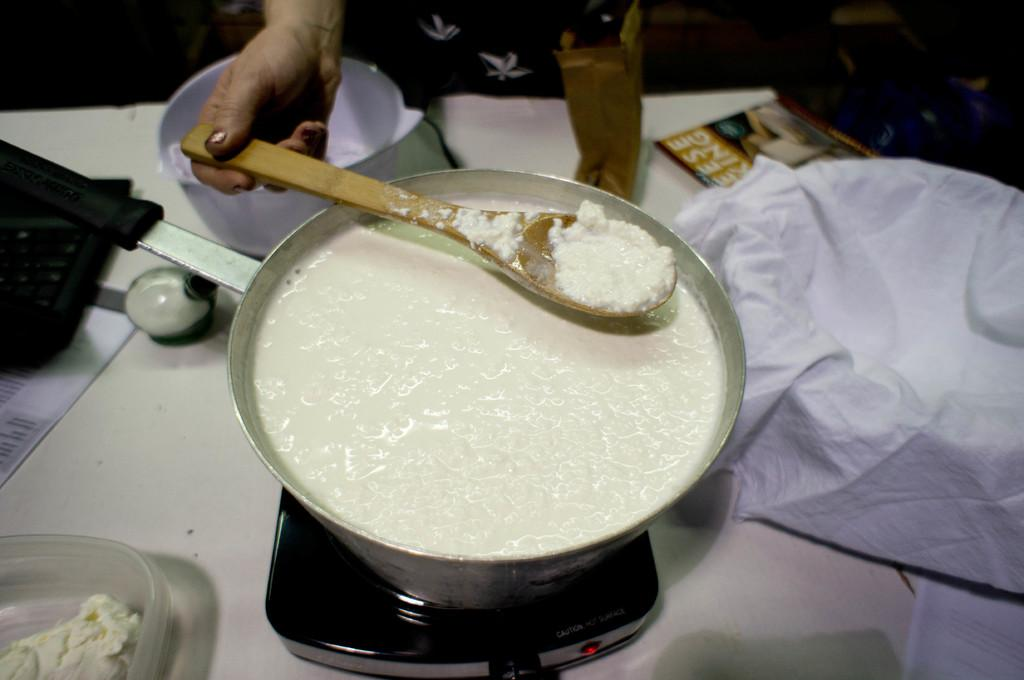<image>
Provide a brief description of the given image. The picture looks like someone making cheese as the magazine on the table have partial words , eese, king.visible on the cover. 